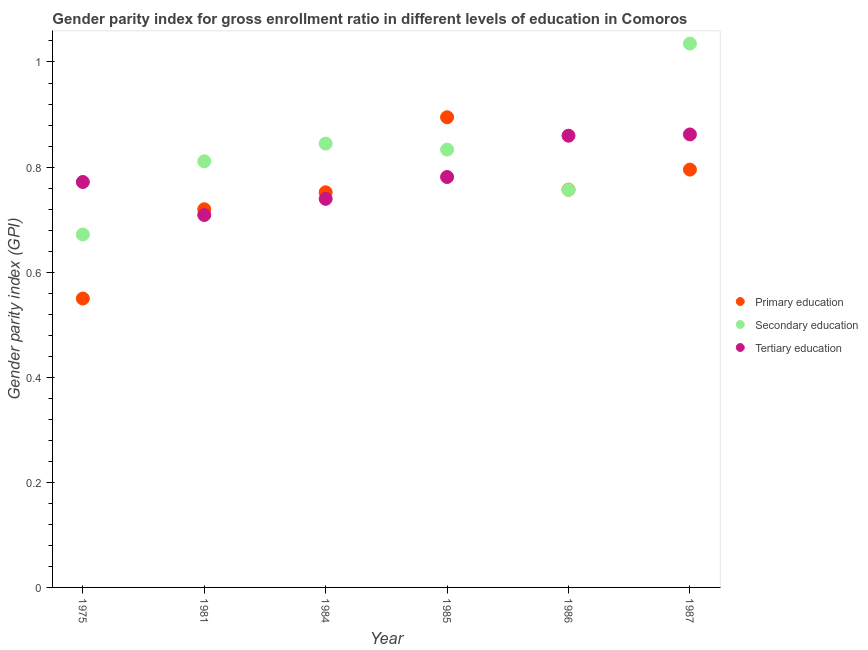How many different coloured dotlines are there?
Your response must be concise. 3. What is the gender parity index in secondary education in 1981?
Make the answer very short. 0.81. Across all years, what is the maximum gender parity index in secondary education?
Provide a short and direct response. 1.04. Across all years, what is the minimum gender parity index in tertiary education?
Your response must be concise. 0.71. In which year was the gender parity index in secondary education minimum?
Give a very brief answer. 1975. What is the total gender parity index in tertiary education in the graph?
Offer a terse response. 4.72. What is the difference between the gender parity index in primary education in 1975 and that in 1986?
Ensure brevity in your answer.  -0.21. What is the difference between the gender parity index in secondary education in 1985 and the gender parity index in primary education in 1986?
Your response must be concise. 0.08. What is the average gender parity index in tertiary education per year?
Offer a very short reply. 0.79. In the year 1986, what is the difference between the gender parity index in tertiary education and gender parity index in secondary education?
Keep it short and to the point. 0.1. In how many years, is the gender parity index in primary education greater than 0.24000000000000002?
Keep it short and to the point. 6. What is the ratio of the gender parity index in primary education in 1975 to that in 1987?
Your answer should be compact. 0.69. Is the gender parity index in secondary education in 1975 less than that in 1981?
Your answer should be very brief. Yes. What is the difference between the highest and the second highest gender parity index in primary education?
Your answer should be compact. 0.1. What is the difference between the highest and the lowest gender parity index in primary education?
Provide a succinct answer. 0.35. In how many years, is the gender parity index in primary education greater than the average gender parity index in primary education taken over all years?
Your response must be concise. 4. Is the sum of the gender parity index in tertiary education in 1984 and 1986 greater than the maximum gender parity index in secondary education across all years?
Provide a short and direct response. Yes. Is it the case that in every year, the sum of the gender parity index in primary education and gender parity index in secondary education is greater than the gender parity index in tertiary education?
Keep it short and to the point. Yes. Is the gender parity index in secondary education strictly greater than the gender parity index in tertiary education over the years?
Give a very brief answer. No. Is the gender parity index in tertiary education strictly less than the gender parity index in secondary education over the years?
Ensure brevity in your answer.  No. What is the difference between two consecutive major ticks on the Y-axis?
Make the answer very short. 0.2. Are the values on the major ticks of Y-axis written in scientific E-notation?
Ensure brevity in your answer.  No. What is the title of the graph?
Offer a terse response. Gender parity index for gross enrollment ratio in different levels of education in Comoros. What is the label or title of the Y-axis?
Keep it short and to the point. Gender parity index (GPI). What is the Gender parity index (GPI) in Primary education in 1975?
Offer a terse response. 0.55. What is the Gender parity index (GPI) of Secondary education in 1975?
Keep it short and to the point. 0.67. What is the Gender parity index (GPI) of Tertiary education in 1975?
Your answer should be very brief. 0.77. What is the Gender parity index (GPI) of Primary education in 1981?
Your answer should be very brief. 0.72. What is the Gender parity index (GPI) in Secondary education in 1981?
Your response must be concise. 0.81. What is the Gender parity index (GPI) in Tertiary education in 1981?
Ensure brevity in your answer.  0.71. What is the Gender parity index (GPI) in Primary education in 1984?
Keep it short and to the point. 0.75. What is the Gender parity index (GPI) in Secondary education in 1984?
Keep it short and to the point. 0.84. What is the Gender parity index (GPI) of Tertiary education in 1984?
Make the answer very short. 0.74. What is the Gender parity index (GPI) of Primary education in 1985?
Provide a short and direct response. 0.89. What is the Gender parity index (GPI) in Secondary education in 1985?
Keep it short and to the point. 0.83. What is the Gender parity index (GPI) of Tertiary education in 1985?
Your response must be concise. 0.78. What is the Gender parity index (GPI) in Primary education in 1986?
Your answer should be compact. 0.76. What is the Gender parity index (GPI) of Secondary education in 1986?
Your response must be concise. 0.76. What is the Gender parity index (GPI) in Tertiary education in 1986?
Your answer should be compact. 0.86. What is the Gender parity index (GPI) in Primary education in 1987?
Keep it short and to the point. 0.8. What is the Gender parity index (GPI) in Secondary education in 1987?
Ensure brevity in your answer.  1.04. What is the Gender parity index (GPI) in Tertiary education in 1987?
Make the answer very short. 0.86. Across all years, what is the maximum Gender parity index (GPI) of Primary education?
Your response must be concise. 0.89. Across all years, what is the maximum Gender parity index (GPI) in Secondary education?
Offer a terse response. 1.04. Across all years, what is the maximum Gender parity index (GPI) in Tertiary education?
Your response must be concise. 0.86. Across all years, what is the minimum Gender parity index (GPI) of Primary education?
Offer a terse response. 0.55. Across all years, what is the minimum Gender parity index (GPI) in Secondary education?
Ensure brevity in your answer.  0.67. Across all years, what is the minimum Gender parity index (GPI) in Tertiary education?
Provide a succinct answer. 0.71. What is the total Gender parity index (GPI) in Primary education in the graph?
Your answer should be very brief. 4.47. What is the total Gender parity index (GPI) of Secondary education in the graph?
Keep it short and to the point. 4.95. What is the total Gender parity index (GPI) in Tertiary education in the graph?
Make the answer very short. 4.72. What is the difference between the Gender parity index (GPI) in Primary education in 1975 and that in 1981?
Your answer should be compact. -0.17. What is the difference between the Gender parity index (GPI) of Secondary education in 1975 and that in 1981?
Keep it short and to the point. -0.14. What is the difference between the Gender parity index (GPI) of Tertiary education in 1975 and that in 1981?
Give a very brief answer. 0.06. What is the difference between the Gender parity index (GPI) in Primary education in 1975 and that in 1984?
Ensure brevity in your answer.  -0.2. What is the difference between the Gender parity index (GPI) of Secondary education in 1975 and that in 1984?
Offer a terse response. -0.17. What is the difference between the Gender parity index (GPI) in Tertiary education in 1975 and that in 1984?
Your answer should be very brief. 0.03. What is the difference between the Gender parity index (GPI) in Primary education in 1975 and that in 1985?
Provide a succinct answer. -0.34. What is the difference between the Gender parity index (GPI) of Secondary education in 1975 and that in 1985?
Your answer should be very brief. -0.16. What is the difference between the Gender parity index (GPI) in Tertiary education in 1975 and that in 1985?
Offer a terse response. -0.01. What is the difference between the Gender parity index (GPI) of Primary education in 1975 and that in 1986?
Offer a terse response. -0.21. What is the difference between the Gender parity index (GPI) in Secondary education in 1975 and that in 1986?
Your response must be concise. -0.09. What is the difference between the Gender parity index (GPI) in Tertiary education in 1975 and that in 1986?
Provide a short and direct response. -0.09. What is the difference between the Gender parity index (GPI) in Primary education in 1975 and that in 1987?
Offer a very short reply. -0.25. What is the difference between the Gender parity index (GPI) of Secondary education in 1975 and that in 1987?
Provide a short and direct response. -0.36. What is the difference between the Gender parity index (GPI) in Tertiary education in 1975 and that in 1987?
Your response must be concise. -0.09. What is the difference between the Gender parity index (GPI) of Primary education in 1981 and that in 1984?
Your answer should be very brief. -0.03. What is the difference between the Gender parity index (GPI) in Secondary education in 1981 and that in 1984?
Offer a very short reply. -0.03. What is the difference between the Gender parity index (GPI) in Tertiary education in 1981 and that in 1984?
Offer a very short reply. -0.03. What is the difference between the Gender parity index (GPI) in Primary education in 1981 and that in 1985?
Make the answer very short. -0.18. What is the difference between the Gender parity index (GPI) in Secondary education in 1981 and that in 1985?
Offer a terse response. -0.02. What is the difference between the Gender parity index (GPI) of Tertiary education in 1981 and that in 1985?
Provide a short and direct response. -0.07. What is the difference between the Gender parity index (GPI) of Primary education in 1981 and that in 1986?
Offer a very short reply. -0.04. What is the difference between the Gender parity index (GPI) of Secondary education in 1981 and that in 1986?
Offer a terse response. 0.05. What is the difference between the Gender parity index (GPI) in Tertiary education in 1981 and that in 1986?
Keep it short and to the point. -0.15. What is the difference between the Gender parity index (GPI) in Primary education in 1981 and that in 1987?
Your answer should be compact. -0.08. What is the difference between the Gender parity index (GPI) in Secondary education in 1981 and that in 1987?
Provide a short and direct response. -0.22. What is the difference between the Gender parity index (GPI) in Tertiary education in 1981 and that in 1987?
Provide a succinct answer. -0.15. What is the difference between the Gender parity index (GPI) of Primary education in 1984 and that in 1985?
Give a very brief answer. -0.14. What is the difference between the Gender parity index (GPI) in Secondary education in 1984 and that in 1985?
Make the answer very short. 0.01. What is the difference between the Gender parity index (GPI) in Tertiary education in 1984 and that in 1985?
Make the answer very short. -0.04. What is the difference between the Gender parity index (GPI) in Primary education in 1984 and that in 1986?
Provide a succinct answer. -0.01. What is the difference between the Gender parity index (GPI) of Secondary education in 1984 and that in 1986?
Offer a very short reply. 0.09. What is the difference between the Gender parity index (GPI) in Tertiary education in 1984 and that in 1986?
Your answer should be very brief. -0.12. What is the difference between the Gender parity index (GPI) of Primary education in 1984 and that in 1987?
Provide a succinct answer. -0.04. What is the difference between the Gender parity index (GPI) of Secondary education in 1984 and that in 1987?
Keep it short and to the point. -0.19. What is the difference between the Gender parity index (GPI) in Tertiary education in 1984 and that in 1987?
Make the answer very short. -0.12. What is the difference between the Gender parity index (GPI) in Primary education in 1985 and that in 1986?
Ensure brevity in your answer.  0.14. What is the difference between the Gender parity index (GPI) in Secondary education in 1985 and that in 1986?
Your answer should be compact. 0.08. What is the difference between the Gender parity index (GPI) in Tertiary education in 1985 and that in 1986?
Your answer should be very brief. -0.08. What is the difference between the Gender parity index (GPI) in Primary education in 1985 and that in 1987?
Your answer should be very brief. 0.1. What is the difference between the Gender parity index (GPI) of Secondary education in 1985 and that in 1987?
Your answer should be compact. -0.2. What is the difference between the Gender parity index (GPI) in Tertiary education in 1985 and that in 1987?
Ensure brevity in your answer.  -0.08. What is the difference between the Gender parity index (GPI) of Primary education in 1986 and that in 1987?
Keep it short and to the point. -0.04. What is the difference between the Gender parity index (GPI) of Secondary education in 1986 and that in 1987?
Your answer should be very brief. -0.28. What is the difference between the Gender parity index (GPI) in Tertiary education in 1986 and that in 1987?
Ensure brevity in your answer.  -0. What is the difference between the Gender parity index (GPI) in Primary education in 1975 and the Gender parity index (GPI) in Secondary education in 1981?
Ensure brevity in your answer.  -0.26. What is the difference between the Gender parity index (GPI) in Primary education in 1975 and the Gender parity index (GPI) in Tertiary education in 1981?
Make the answer very short. -0.16. What is the difference between the Gender parity index (GPI) of Secondary education in 1975 and the Gender parity index (GPI) of Tertiary education in 1981?
Ensure brevity in your answer.  -0.04. What is the difference between the Gender parity index (GPI) in Primary education in 1975 and the Gender parity index (GPI) in Secondary education in 1984?
Ensure brevity in your answer.  -0.29. What is the difference between the Gender parity index (GPI) in Primary education in 1975 and the Gender parity index (GPI) in Tertiary education in 1984?
Your answer should be compact. -0.19. What is the difference between the Gender parity index (GPI) in Secondary education in 1975 and the Gender parity index (GPI) in Tertiary education in 1984?
Provide a succinct answer. -0.07. What is the difference between the Gender parity index (GPI) in Primary education in 1975 and the Gender parity index (GPI) in Secondary education in 1985?
Provide a succinct answer. -0.28. What is the difference between the Gender parity index (GPI) in Primary education in 1975 and the Gender parity index (GPI) in Tertiary education in 1985?
Make the answer very short. -0.23. What is the difference between the Gender parity index (GPI) of Secondary education in 1975 and the Gender parity index (GPI) of Tertiary education in 1985?
Your response must be concise. -0.11. What is the difference between the Gender parity index (GPI) of Primary education in 1975 and the Gender parity index (GPI) of Secondary education in 1986?
Provide a succinct answer. -0.21. What is the difference between the Gender parity index (GPI) of Primary education in 1975 and the Gender parity index (GPI) of Tertiary education in 1986?
Your answer should be compact. -0.31. What is the difference between the Gender parity index (GPI) in Secondary education in 1975 and the Gender parity index (GPI) in Tertiary education in 1986?
Give a very brief answer. -0.19. What is the difference between the Gender parity index (GPI) of Primary education in 1975 and the Gender parity index (GPI) of Secondary education in 1987?
Your answer should be compact. -0.49. What is the difference between the Gender parity index (GPI) of Primary education in 1975 and the Gender parity index (GPI) of Tertiary education in 1987?
Keep it short and to the point. -0.31. What is the difference between the Gender parity index (GPI) of Secondary education in 1975 and the Gender parity index (GPI) of Tertiary education in 1987?
Make the answer very short. -0.19. What is the difference between the Gender parity index (GPI) of Primary education in 1981 and the Gender parity index (GPI) of Secondary education in 1984?
Offer a very short reply. -0.12. What is the difference between the Gender parity index (GPI) of Primary education in 1981 and the Gender parity index (GPI) of Tertiary education in 1984?
Make the answer very short. -0.02. What is the difference between the Gender parity index (GPI) in Secondary education in 1981 and the Gender parity index (GPI) in Tertiary education in 1984?
Make the answer very short. 0.07. What is the difference between the Gender parity index (GPI) in Primary education in 1981 and the Gender parity index (GPI) in Secondary education in 1985?
Offer a terse response. -0.11. What is the difference between the Gender parity index (GPI) in Primary education in 1981 and the Gender parity index (GPI) in Tertiary education in 1985?
Ensure brevity in your answer.  -0.06. What is the difference between the Gender parity index (GPI) of Secondary education in 1981 and the Gender parity index (GPI) of Tertiary education in 1985?
Give a very brief answer. 0.03. What is the difference between the Gender parity index (GPI) in Primary education in 1981 and the Gender parity index (GPI) in Secondary education in 1986?
Your answer should be compact. -0.04. What is the difference between the Gender parity index (GPI) of Primary education in 1981 and the Gender parity index (GPI) of Tertiary education in 1986?
Offer a very short reply. -0.14. What is the difference between the Gender parity index (GPI) in Secondary education in 1981 and the Gender parity index (GPI) in Tertiary education in 1986?
Provide a short and direct response. -0.05. What is the difference between the Gender parity index (GPI) of Primary education in 1981 and the Gender parity index (GPI) of Secondary education in 1987?
Provide a short and direct response. -0.32. What is the difference between the Gender parity index (GPI) of Primary education in 1981 and the Gender parity index (GPI) of Tertiary education in 1987?
Your response must be concise. -0.14. What is the difference between the Gender parity index (GPI) of Secondary education in 1981 and the Gender parity index (GPI) of Tertiary education in 1987?
Offer a terse response. -0.05. What is the difference between the Gender parity index (GPI) of Primary education in 1984 and the Gender parity index (GPI) of Secondary education in 1985?
Ensure brevity in your answer.  -0.08. What is the difference between the Gender parity index (GPI) in Primary education in 1984 and the Gender parity index (GPI) in Tertiary education in 1985?
Make the answer very short. -0.03. What is the difference between the Gender parity index (GPI) in Secondary education in 1984 and the Gender parity index (GPI) in Tertiary education in 1985?
Ensure brevity in your answer.  0.06. What is the difference between the Gender parity index (GPI) in Primary education in 1984 and the Gender parity index (GPI) in Secondary education in 1986?
Keep it short and to the point. -0. What is the difference between the Gender parity index (GPI) in Primary education in 1984 and the Gender parity index (GPI) in Tertiary education in 1986?
Provide a short and direct response. -0.11. What is the difference between the Gender parity index (GPI) of Secondary education in 1984 and the Gender parity index (GPI) of Tertiary education in 1986?
Provide a succinct answer. -0.01. What is the difference between the Gender parity index (GPI) of Primary education in 1984 and the Gender parity index (GPI) of Secondary education in 1987?
Provide a succinct answer. -0.28. What is the difference between the Gender parity index (GPI) in Primary education in 1984 and the Gender parity index (GPI) in Tertiary education in 1987?
Your response must be concise. -0.11. What is the difference between the Gender parity index (GPI) of Secondary education in 1984 and the Gender parity index (GPI) of Tertiary education in 1987?
Provide a succinct answer. -0.02. What is the difference between the Gender parity index (GPI) of Primary education in 1985 and the Gender parity index (GPI) of Secondary education in 1986?
Your answer should be very brief. 0.14. What is the difference between the Gender parity index (GPI) in Primary education in 1985 and the Gender parity index (GPI) in Tertiary education in 1986?
Your answer should be very brief. 0.04. What is the difference between the Gender parity index (GPI) in Secondary education in 1985 and the Gender parity index (GPI) in Tertiary education in 1986?
Your answer should be very brief. -0.03. What is the difference between the Gender parity index (GPI) in Primary education in 1985 and the Gender parity index (GPI) in Secondary education in 1987?
Your answer should be compact. -0.14. What is the difference between the Gender parity index (GPI) of Primary education in 1985 and the Gender parity index (GPI) of Tertiary education in 1987?
Your response must be concise. 0.03. What is the difference between the Gender parity index (GPI) of Secondary education in 1985 and the Gender parity index (GPI) of Tertiary education in 1987?
Offer a very short reply. -0.03. What is the difference between the Gender parity index (GPI) of Primary education in 1986 and the Gender parity index (GPI) of Secondary education in 1987?
Provide a succinct answer. -0.28. What is the difference between the Gender parity index (GPI) in Primary education in 1986 and the Gender parity index (GPI) in Tertiary education in 1987?
Make the answer very short. -0.1. What is the difference between the Gender parity index (GPI) in Secondary education in 1986 and the Gender parity index (GPI) in Tertiary education in 1987?
Provide a succinct answer. -0.11. What is the average Gender parity index (GPI) of Primary education per year?
Offer a terse response. 0.74. What is the average Gender parity index (GPI) in Secondary education per year?
Your response must be concise. 0.83. What is the average Gender parity index (GPI) in Tertiary education per year?
Make the answer very short. 0.79. In the year 1975, what is the difference between the Gender parity index (GPI) in Primary education and Gender parity index (GPI) in Secondary education?
Provide a succinct answer. -0.12. In the year 1975, what is the difference between the Gender parity index (GPI) of Primary education and Gender parity index (GPI) of Tertiary education?
Offer a very short reply. -0.22. In the year 1975, what is the difference between the Gender parity index (GPI) of Secondary education and Gender parity index (GPI) of Tertiary education?
Keep it short and to the point. -0.1. In the year 1981, what is the difference between the Gender parity index (GPI) in Primary education and Gender parity index (GPI) in Secondary education?
Give a very brief answer. -0.09. In the year 1981, what is the difference between the Gender parity index (GPI) in Primary education and Gender parity index (GPI) in Tertiary education?
Ensure brevity in your answer.  0.01. In the year 1981, what is the difference between the Gender parity index (GPI) of Secondary education and Gender parity index (GPI) of Tertiary education?
Offer a terse response. 0.1. In the year 1984, what is the difference between the Gender parity index (GPI) in Primary education and Gender parity index (GPI) in Secondary education?
Keep it short and to the point. -0.09. In the year 1984, what is the difference between the Gender parity index (GPI) of Primary education and Gender parity index (GPI) of Tertiary education?
Provide a succinct answer. 0.01. In the year 1984, what is the difference between the Gender parity index (GPI) in Secondary education and Gender parity index (GPI) in Tertiary education?
Provide a succinct answer. 0.11. In the year 1985, what is the difference between the Gender parity index (GPI) in Primary education and Gender parity index (GPI) in Secondary education?
Offer a terse response. 0.06. In the year 1985, what is the difference between the Gender parity index (GPI) in Primary education and Gender parity index (GPI) in Tertiary education?
Provide a succinct answer. 0.11. In the year 1985, what is the difference between the Gender parity index (GPI) in Secondary education and Gender parity index (GPI) in Tertiary education?
Provide a succinct answer. 0.05. In the year 1986, what is the difference between the Gender parity index (GPI) of Primary education and Gender parity index (GPI) of Tertiary education?
Make the answer very short. -0.1. In the year 1986, what is the difference between the Gender parity index (GPI) of Secondary education and Gender parity index (GPI) of Tertiary education?
Make the answer very short. -0.1. In the year 1987, what is the difference between the Gender parity index (GPI) in Primary education and Gender parity index (GPI) in Secondary education?
Provide a succinct answer. -0.24. In the year 1987, what is the difference between the Gender parity index (GPI) in Primary education and Gender parity index (GPI) in Tertiary education?
Ensure brevity in your answer.  -0.07. In the year 1987, what is the difference between the Gender parity index (GPI) of Secondary education and Gender parity index (GPI) of Tertiary education?
Ensure brevity in your answer.  0.17. What is the ratio of the Gender parity index (GPI) in Primary education in 1975 to that in 1981?
Your answer should be very brief. 0.76. What is the ratio of the Gender parity index (GPI) in Secondary education in 1975 to that in 1981?
Provide a short and direct response. 0.83. What is the ratio of the Gender parity index (GPI) of Tertiary education in 1975 to that in 1981?
Provide a succinct answer. 1.09. What is the ratio of the Gender parity index (GPI) in Primary education in 1975 to that in 1984?
Your answer should be very brief. 0.73. What is the ratio of the Gender parity index (GPI) in Secondary education in 1975 to that in 1984?
Offer a terse response. 0.8. What is the ratio of the Gender parity index (GPI) in Tertiary education in 1975 to that in 1984?
Offer a very short reply. 1.04. What is the ratio of the Gender parity index (GPI) of Primary education in 1975 to that in 1985?
Your response must be concise. 0.61. What is the ratio of the Gender parity index (GPI) in Secondary education in 1975 to that in 1985?
Provide a short and direct response. 0.81. What is the ratio of the Gender parity index (GPI) of Primary education in 1975 to that in 1986?
Your response must be concise. 0.73. What is the ratio of the Gender parity index (GPI) of Secondary education in 1975 to that in 1986?
Provide a short and direct response. 0.89. What is the ratio of the Gender parity index (GPI) of Tertiary education in 1975 to that in 1986?
Offer a very short reply. 0.9. What is the ratio of the Gender parity index (GPI) in Primary education in 1975 to that in 1987?
Your answer should be very brief. 0.69. What is the ratio of the Gender parity index (GPI) in Secondary education in 1975 to that in 1987?
Keep it short and to the point. 0.65. What is the ratio of the Gender parity index (GPI) in Tertiary education in 1975 to that in 1987?
Give a very brief answer. 0.9. What is the ratio of the Gender parity index (GPI) in Primary education in 1981 to that in 1984?
Ensure brevity in your answer.  0.96. What is the ratio of the Gender parity index (GPI) of Secondary education in 1981 to that in 1984?
Ensure brevity in your answer.  0.96. What is the ratio of the Gender parity index (GPI) in Tertiary education in 1981 to that in 1984?
Your response must be concise. 0.96. What is the ratio of the Gender parity index (GPI) of Primary education in 1981 to that in 1985?
Offer a terse response. 0.8. What is the ratio of the Gender parity index (GPI) in Secondary education in 1981 to that in 1985?
Make the answer very short. 0.97. What is the ratio of the Gender parity index (GPI) in Tertiary education in 1981 to that in 1985?
Provide a succinct answer. 0.91. What is the ratio of the Gender parity index (GPI) of Primary education in 1981 to that in 1986?
Give a very brief answer. 0.95. What is the ratio of the Gender parity index (GPI) in Secondary education in 1981 to that in 1986?
Provide a short and direct response. 1.07. What is the ratio of the Gender parity index (GPI) in Tertiary education in 1981 to that in 1986?
Offer a terse response. 0.82. What is the ratio of the Gender parity index (GPI) of Primary education in 1981 to that in 1987?
Keep it short and to the point. 0.91. What is the ratio of the Gender parity index (GPI) in Secondary education in 1981 to that in 1987?
Your response must be concise. 0.78. What is the ratio of the Gender parity index (GPI) of Tertiary education in 1981 to that in 1987?
Provide a short and direct response. 0.82. What is the ratio of the Gender parity index (GPI) of Primary education in 1984 to that in 1985?
Your response must be concise. 0.84. What is the ratio of the Gender parity index (GPI) in Secondary education in 1984 to that in 1985?
Provide a succinct answer. 1.01. What is the ratio of the Gender parity index (GPI) of Tertiary education in 1984 to that in 1985?
Make the answer very short. 0.95. What is the ratio of the Gender parity index (GPI) in Secondary education in 1984 to that in 1986?
Offer a very short reply. 1.12. What is the ratio of the Gender parity index (GPI) of Tertiary education in 1984 to that in 1986?
Your response must be concise. 0.86. What is the ratio of the Gender parity index (GPI) in Primary education in 1984 to that in 1987?
Provide a short and direct response. 0.95. What is the ratio of the Gender parity index (GPI) of Secondary education in 1984 to that in 1987?
Provide a short and direct response. 0.82. What is the ratio of the Gender parity index (GPI) in Tertiary education in 1984 to that in 1987?
Provide a short and direct response. 0.86. What is the ratio of the Gender parity index (GPI) in Primary education in 1985 to that in 1986?
Offer a terse response. 1.18. What is the ratio of the Gender parity index (GPI) of Secondary education in 1985 to that in 1986?
Keep it short and to the point. 1.1. What is the ratio of the Gender parity index (GPI) of Tertiary education in 1985 to that in 1986?
Provide a short and direct response. 0.91. What is the ratio of the Gender parity index (GPI) of Primary education in 1985 to that in 1987?
Your answer should be very brief. 1.13. What is the ratio of the Gender parity index (GPI) of Secondary education in 1985 to that in 1987?
Offer a terse response. 0.81. What is the ratio of the Gender parity index (GPI) of Tertiary education in 1985 to that in 1987?
Your answer should be very brief. 0.91. What is the ratio of the Gender parity index (GPI) in Primary education in 1986 to that in 1987?
Offer a terse response. 0.95. What is the ratio of the Gender parity index (GPI) in Secondary education in 1986 to that in 1987?
Provide a short and direct response. 0.73. What is the difference between the highest and the second highest Gender parity index (GPI) in Primary education?
Offer a terse response. 0.1. What is the difference between the highest and the second highest Gender parity index (GPI) in Secondary education?
Offer a very short reply. 0.19. What is the difference between the highest and the second highest Gender parity index (GPI) of Tertiary education?
Your answer should be very brief. 0. What is the difference between the highest and the lowest Gender parity index (GPI) of Primary education?
Offer a very short reply. 0.34. What is the difference between the highest and the lowest Gender parity index (GPI) of Secondary education?
Provide a succinct answer. 0.36. What is the difference between the highest and the lowest Gender parity index (GPI) in Tertiary education?
Give a very brief answer. 0.15. 